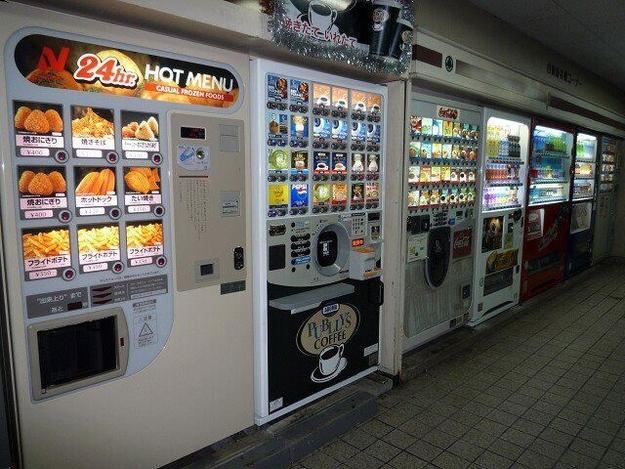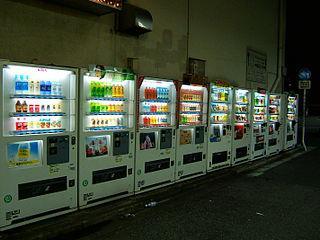The first image is the image on the left, the second image is the image on the right. Assess this claim about the two images: "None of the images show more than two vending machines.". Correct or not? Answer yes or no. No. The first image is the image on the left, the second image is the image on the right. Examine the images to the left and right. Is the description "There are no more than two vending machines in the image on the right." accurate? Answer yes or no. No. 